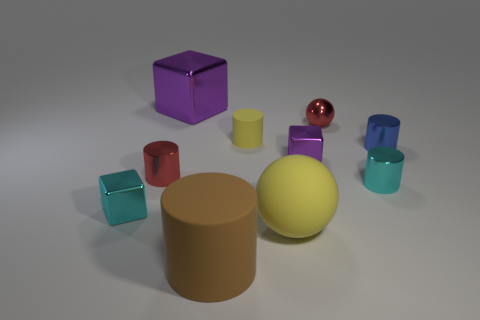Considering their relative sizes, what educational concepts could these objects help illustrate? These objects are excellent for demonstrating principles of geometry, spatial relationships, proportion, and comparative sizes. For example, they could be used to teach about volume and area or to compare the properties of different geometrical figures. 